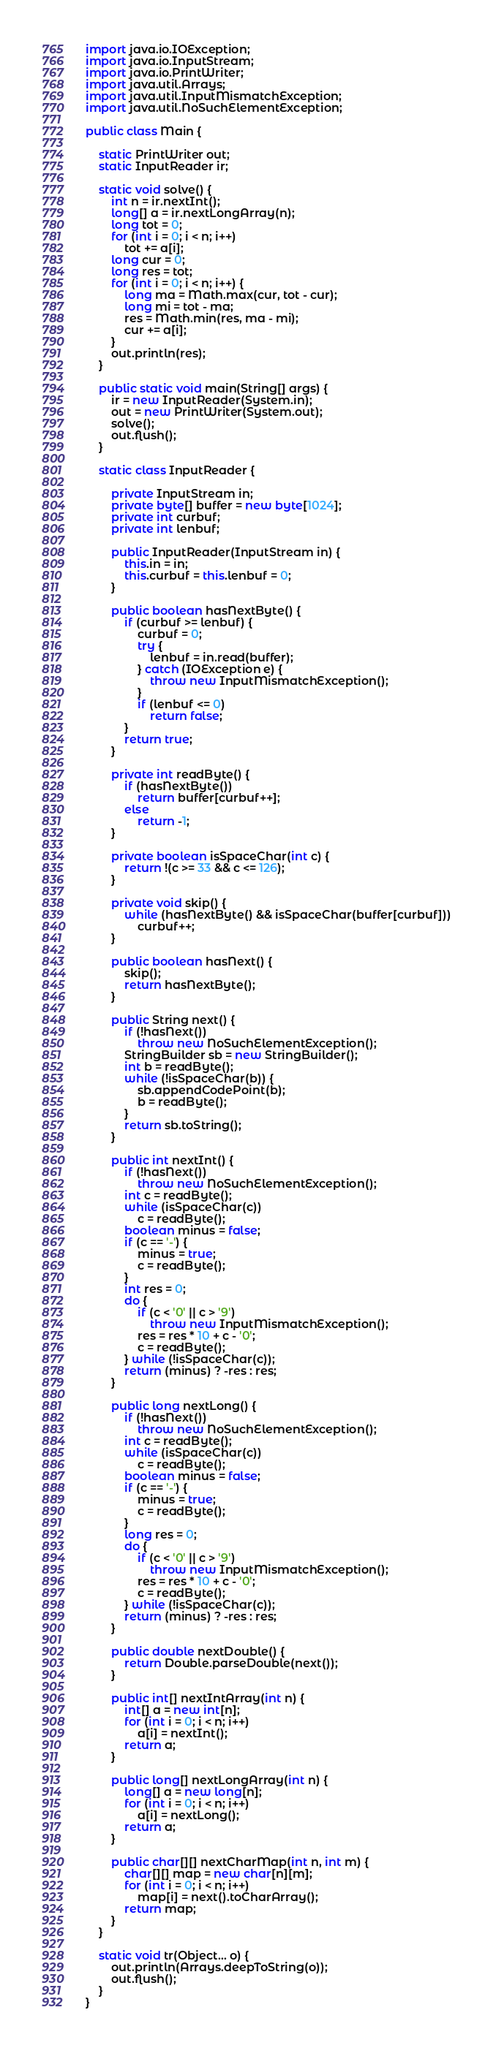Convert code to text. <code><loc_0><loc_0><loc_500><loc_500><_Java_>import java.io.IOException;
import java.io.InputStream;
import java.io.PrintWriter;
import java.util.Arrays;
import java.util.InputMismatchException;
import java.util.NoSuchElementException;

public class Main {

	static PrintWriter out;
	static InputReader ir;

	static void solve() {
		int n = ir.nextInt();
		long[] a = ir.nextLongArray(n);
		long tot = 0;
		for (int i = 0; i < n; i++)
			tot += a[i];
		long cur = 0;
		long res = tot;
		for (int i = 0; i < n; i++) {
			long ma = Math.max(cur, tot - cur);
			long mi = tot - ma;
			res = Math.min(res, ma - mi);
			cur += a[i];
		}
		out.println(res);
	}

	public static void main(String[] args) {
		ir = new InputReader(System.in);
		out = new PrintWriter(System.out);
		solve();
		out.flush();
	}

	static class InputReader {

		private InputStream in;
		private byte[] buffer = new byte[1024];
		private int curbuf;
		private int lenbuf;

		public InputReader(InputStream in) {
			this.in = in;
			this.curbuf = this.lenbuf = 0;
		}

		public boolean hasNextByte() {
			if (curbuf >= lenbuf) {
				curbuf = 0;
				try {
					lenbuf = in.read(buffer);
				} catch (IOException e) {
					throw new InputMismatchException();
				}
				if (lenbuf <= 0)
					return false;
			}
			return true;
		}

		private int readByte() {
			if (hasNextByte())
				return buffer[curbuf++];
			else
				return -1;
		}

		private boolean isSpaceChar(int c) {
			return !(c >= 33 && c <= 126);
		}

		private void skip() {
			while (hasNextByte() && isSpaceChar(buffer[curbuf]))
				curbuf++;
		}

		public boolean hasNext() {
			skip();
			return hasNextByte();
		}

		public String next() {
			if (!hasNext())
				throw new NoSuchElementException();
			StringBuilder sb = new StringBuilder();
			int b = readByte();
			while (!isSpaceChar(b)) {
				sb.appendCodePoint(b);
				b = readByte();
			}
			return sb.toString();
		}

		public int nextInt() {
			if (!hasNext())
				throw new NoSuchElementException();
			int c = readByte();
			while (isSpaceChar(c))
				c = readByte();
			boolean minus = false;
			if (c == '-') {
				minus = true;
				c = readByte();
			}
			int res = 0;
			do {
				if (c < '0' || c > '9')
					throw new InputMismatchException();
				res = res * 10 + c - '0';
				c = readByte();
			} while (!isSpaceChar(c));
			return (minus) ? -res : res;
		}

		public long nextLong() {
			if (!hasNext())
				throw new NoSuchElementException();
			int c = readByte();
			while (isSpaceChar(c))
				c = readByte();
			boolean minus = false;
			if (c == '-') {
				minus = true;
				c = readByte();
			}
			long res = 0;
			do {
				if (c < '0' || c > '9')
					throw new InputMismatchException();
				res = res * 10 + c - '0';
				c = readByte();
			} while (!isSpaceChar(c));
			return (minus) ? -res : res;
		}

		public double nextDouble() {
			return Double.parseDouble(next());
		}

		public int[] nextIntArray(int n) {
			int[] a = new int[n];
			for (int i = 0; i < n; i++)
				a[i] = nextInt();
			return a;
		}

		public long[] nextLongArray(int n) {
			long[] a = new long[n];
			for (int i = 0; i < n; i++)
				a[i] = nextLong();
			return a;
		}

		public char[][] nextCharMap(int n, int m) {
			char[][] map = new char[n][m];
			for (int i = 0; i < n; i++)
				map[i] = next().toCharArray();
			return map;
		}
	}

	static void tr(Object... o) {
		out.println(Arrays.deepToString(o));
		out.flush();
	}
}
</code> 